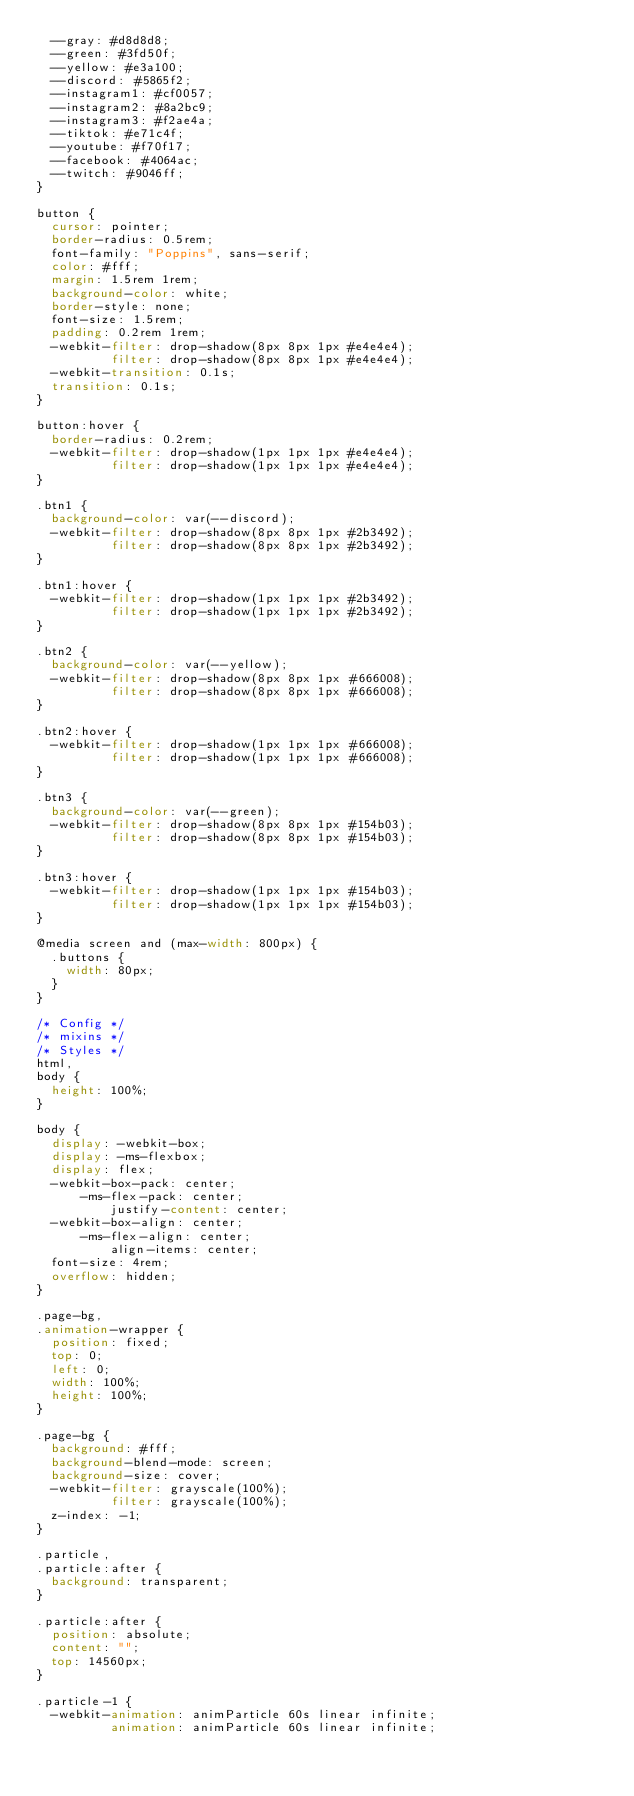Convert code to text. <code><loc_0><loc_0><loc_500><loc_500><_CSS_>  --gray: #d8d8d8;
  --green: #3fd50f;
  --yellow: #e3a100;
  --discord: #5865f2;
  --instagram1: #cf0057;
  --instagram2: #8a2bc9;
  --instagram3: #f2ae4a;
  --tiktok: #e71c4f;
  --youtube: #f70f17;
  --facebook: #4064ac;
  --twitch: #9046ff;
}

button {
  cursor: pointer;
  border-radius: 0.5rem;
  font-family: "Poppins", sans-serif;
  color: #fff;
  margin: 1.5rem 1rem;
  background-color: white;
  border-style: none;
  font-size: 1.5rem;
  padding: 0.2rem 1rem;
  -webkit-filter: drop-shadow(8px 8px 1px #e4e4e4);
          filter: drop-shadow(8px 8px 1px #e4e4e4);
  -webkit-transition: 0.1s;
  transition: 0.1s;
}

button:hover {
  border-radius: 0.2rem;
  -webkit-filter: drop-shadow(1px 1px 1px #e4e4e4);
          filter: drop-shadow(1px 1px 1px #e4e4e4);
}

.btn1 {
  background-color: var(--discord);
  -webkit-filter: drop-shadow(8px 8px 1px #2b3492);
          filter: drop-shadow(8px 8px 1px #2b3492);
}

.btn1:hover {
  -webkit-filter: drop-shadow(1px 1px 1px #2b3492);
          filter: drop-shadow(1px 1px 1px #2b3492);
}

.btn2 {
  background-color: var(--yellow);
  -webkit-filter: drop-shadow(8px 8px 1px #666008);
          filter: drop-shadow(8px 8px 1px #666008);
}

.btn2:hover {
  -webkit-filter: drop-shadow(1px 1px 1px #666008);
          filter: drop-shadow(1px 1px 1px #666008);
}

.btn3 {
  background-color: var(--green);
  -webkit-filter: drop-shadow(8px 8px 1px #154b03);
          filter: drop-shadow(8px 8px 1px #154b03);
}

.btn3:hover {
  -webkit-filter: drop-shadow(1px 1px 1px #154b03);
          filter: drop-shadow(1px 1px 1px #154b03);
}

@media screen and (max-width: 800px) {
  .buttons {
    width: 80px;
  }
}

/* Config */
/* mixins */
/* Styles */
html,
body {
  height: 100%;
}

body {
  display: -webkit-box;
  display: -ms-flexbox;
  display: flex;
  -webkit-box-pack: center;
      -ms-flex-pack: center;
          justify-content: center;
  -webkit-box-align: center;
      -ms-flex-align: center;
          align-items: center;
  font-size: 4rem;
  overflow: hidden;
}

.page-bg,
.animation-wrapper {
  position: fixed;
  top: 0;
  left: 0;
  width: 100%;
  height: 100%;
}

.page-bg {
  background: #fff;
  background-blend-mode: screen;
  background-size: cover;
  -webkit-filter: grayscale(100%);
          filter: grayscale(100%);
  z-index: -1;
}

.particle,
.particle:after {
  background: transparent;
}

.particle:after {
  position: absolute;
  content: "";
  top: 14560px;
}

.particle-1 {
  -webkit-animation: animParticle 60s linear infinite;
          animation: animParticle 60s linear infinite;</code> 